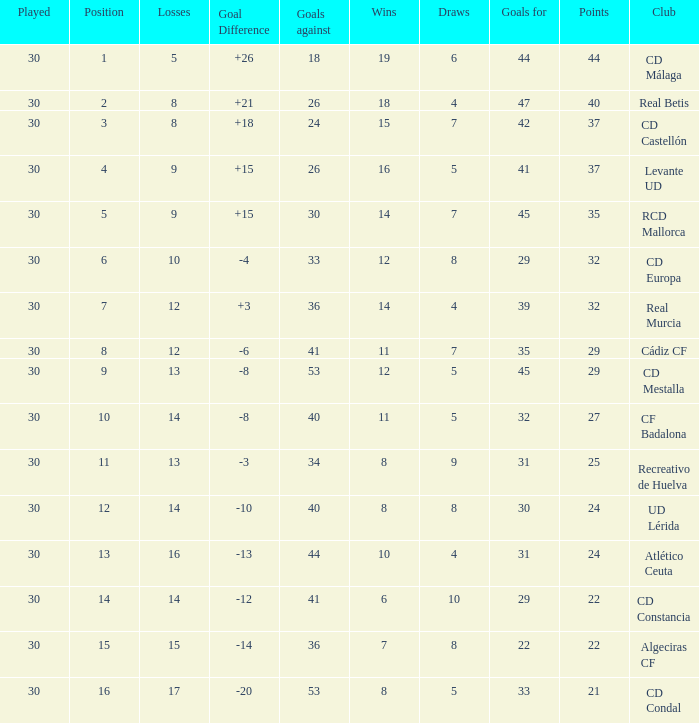What is the number of draws when played is smaller than 30? 0.0. 